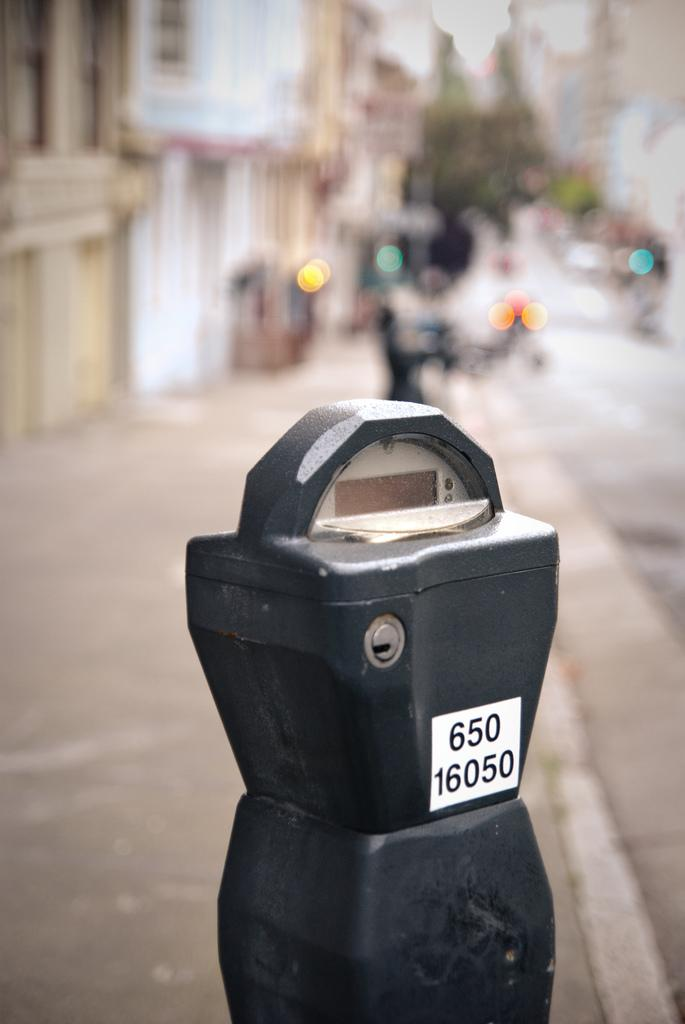What is the main object in the front of the image? There is a black color box in the front of the image. What can be seen in the background of the image? There are trees and buildings in the background of the image. How is the background of the image depicted? The background is slightly blurred. How many legs are visible under the black color box in the image? There are no legs visible under the black color box in the image. Is there a veil covering the trees in the background of the image? There is no veil present in the image; the trees are visible without any covering. 